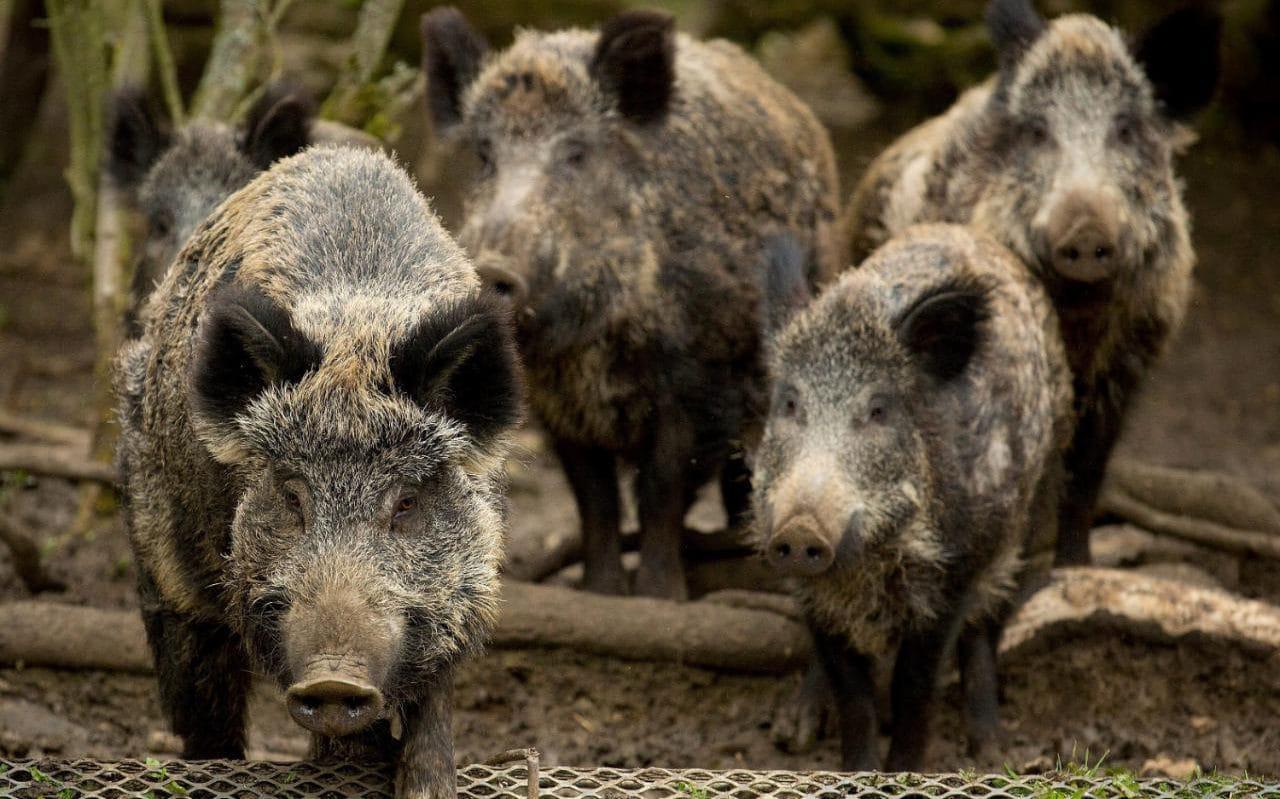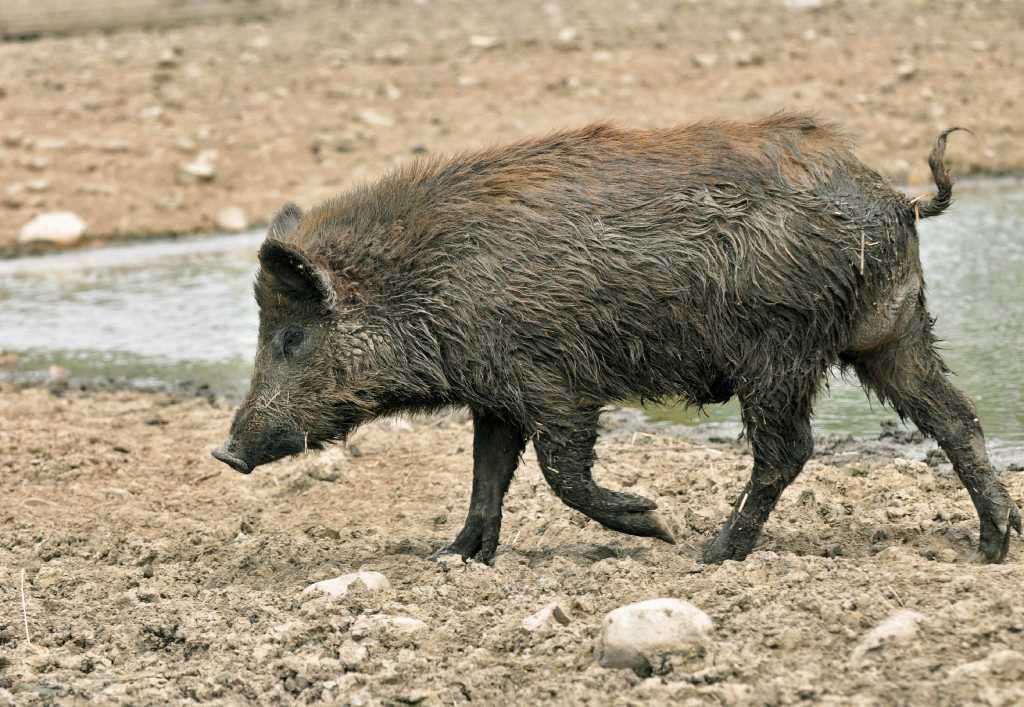The first image is the image on the left, the second image is the image on the right. Considering the images on both sides, is "At least one pig is in a walking pose heading leftward." valid? Answer yes or no. Yes. The first image is the image on the left, the second image is the image on the right. Analyze the images presented: Is the assertion "The pig in the image on the right is near a body of water." valid? Answer yes or no. Yes. 